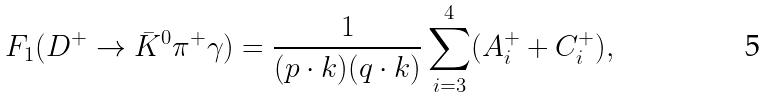<formula> <loc_0><loc_0><loc_500><loc_500>F _ { 1 } ( D ^ { + } \to \bar { K } ^ { 0 } \pi ^ { + } \gamma ) = \frac { 1 } { ( p \cdot k ) ( q \cdot k ) } \sum _ { i = 3 } ^ { 4 } ( A _ { i } ^ { + } + C _ { i } ^ { + } ) ,</formula> 